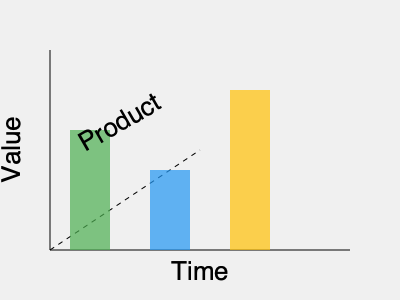In the 3D bar graph representing customer data trends, which product category shows the highest growth over time? To determine which product category shows the highest growth over time, we need to analyze the height of each bar in the 3D graph:

1. The graph shows three product categories represented by different colored bars:
   - Green bar (left): Represents the first product category
   - Blue bar (middle): Represents the second product category
   - Yellow bar (right): Represents the third product category

2. The height of each bar indicates the value or performance of each product category over time.

3. Comparing the heights:
   - Green bar: Approximately 120 units tall
   - Blue bar: Approximately 80 units tall
   - Yellow bar: Approximately 160 units tall

4. The yellow bar (right-most) is the tallest among the three, indicating the highest value or performance.

5. Since the x-axis represents time, we can infer that the yellow bar shows the highest point reached over the given time period.

Therefore, the product category represented by the yellow bar (right-most) shows the highest growth over time.
Answer: Yellow (right-most) bar 